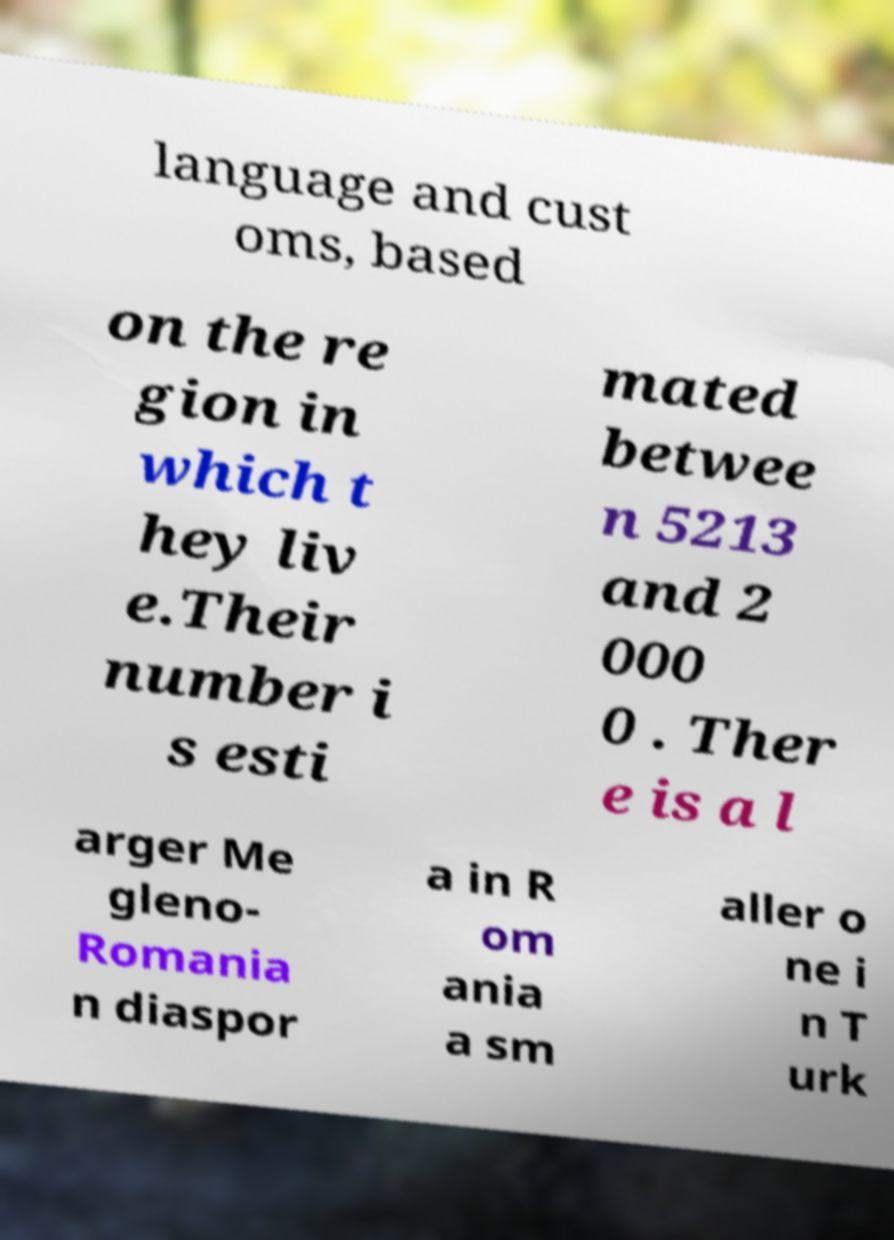Can you accurately transcribe the text from the provided image for me? language and cust oms, based on the re gion in which t hey liv e.Their number i s esti mated betwee n 5213 and 2 000 0 . Ther e is a l arger Me gleno- Romania n diaspor a in R om ania a sm aller o ne i n T urk 